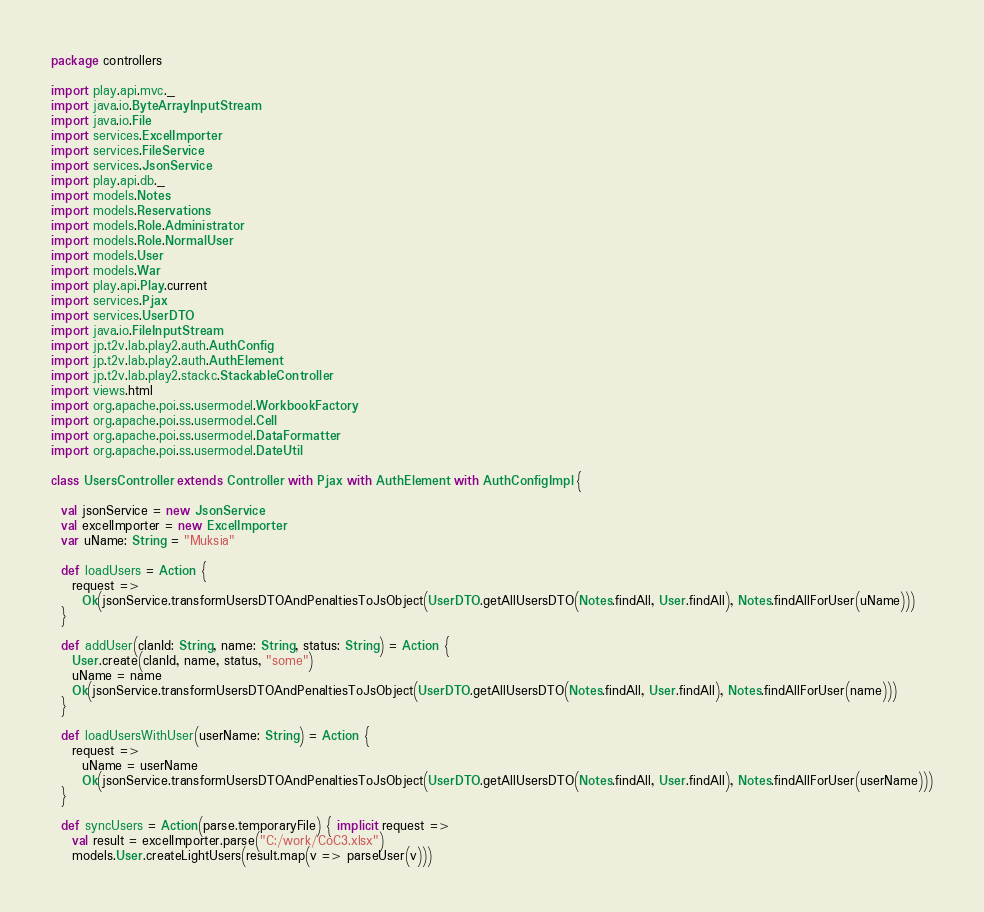Convert code to text. <code><loc_0><loc_0><loc_500><loc_500><_Scala_>package controllers

import play.api.mvc._
import java.io.ByteArrayInputStream
import java.io.File
import services.ExcelImporter
import services.FileService
import services.JsonService
import play.api.db._
import models.Notes
import models.Reservations
import models.Role.Administrator
import models.Role.NormalUser
import models.User
import models.War
import play.api.Play.current
import services.Pjax
import services.UserDTO
import java.io.FileInputStream
import jp.t2v.lab.play2.auth.AuthConfig
import jp.t2v.lab.play2.auth.AuthElement
import jp.t2v.lab.play2.stackc.StackableController
import views.html
import org.apache.poi.ss.usermodel.WorkbookFactory
import org.apache.poi.ss.usermodel.Cell
import org.apache.poi.ss.usermodel.DataFormatter
import org.apache.poi.ss.usermodel.DateUtil

class UsersController extends Controller with Pjax with AuthElement with AuthConfigImpl {

  val jsonService = new JsonService
  val excelImporter = new ExcelImporter
  var uName: String = "Muksia"

  def loadUsers = Action {
    request =>
      Ok(jsonService.transformUsersDTOAndPenaltiesToJsObject(UserDTO.getAllUsersDTO(Notes.findAll, User.findAll), Notes.findAllForUser(uName)))
  }

  def addUser(clanId: String, name: String, status: String) = Action {
    User.create(clanId, name, status, "some")
    uName = name
    Ok(jsonService.transformUsersDTOAndPenaltiesToJsObject(UserDTO.getAllUsersDTO(Notes.findAll, User.findAll), Notes.findAllForUser(name)))
  }

  def loadUsersWithUser(userName: String) = Action {
    request =>
      uName = userName
      Ok(jsonService.transformUsersDTOAndPenaltiesToJsObject(UserDTO.getAllUsersDTO(Notes.findAll, User.findAll), Notes.findAllForUser(userName)))
  }

  def syncUsers = Action(parse.temporaryFile) { implicit request =>
    val result = excelImporter.parse("C:/work/CoC3.xlsx")
    models.User.createLightUsers(result.map(v => parseUser(v)))</code> 